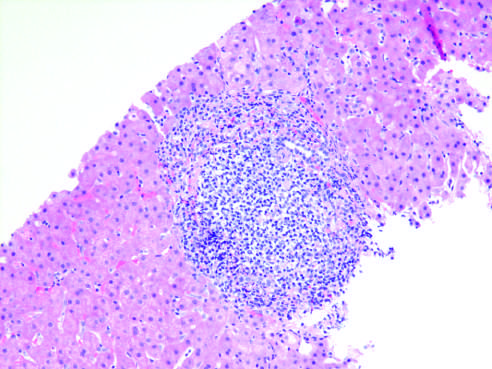how did chronic viral hepatitis due to hcv show characteristic portal tract expansion?
Answer the question using a single word or phrase. By a dense lymphoid infiltrate 